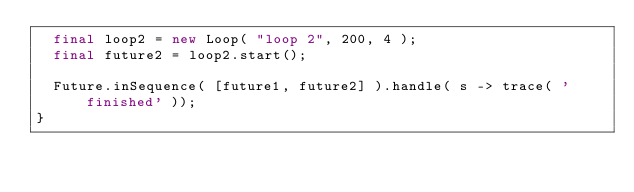<code> <loc_0><loc_0><loc_500><loc_500><_Haxe_>	final loop2 = new Loop( "loop 2", 200, 4 );
	final future2 = loop2.start();
	
	Future.inSequence( [future1, future2] ).handle( s -> trace( 'finished' ));
}
</code> 